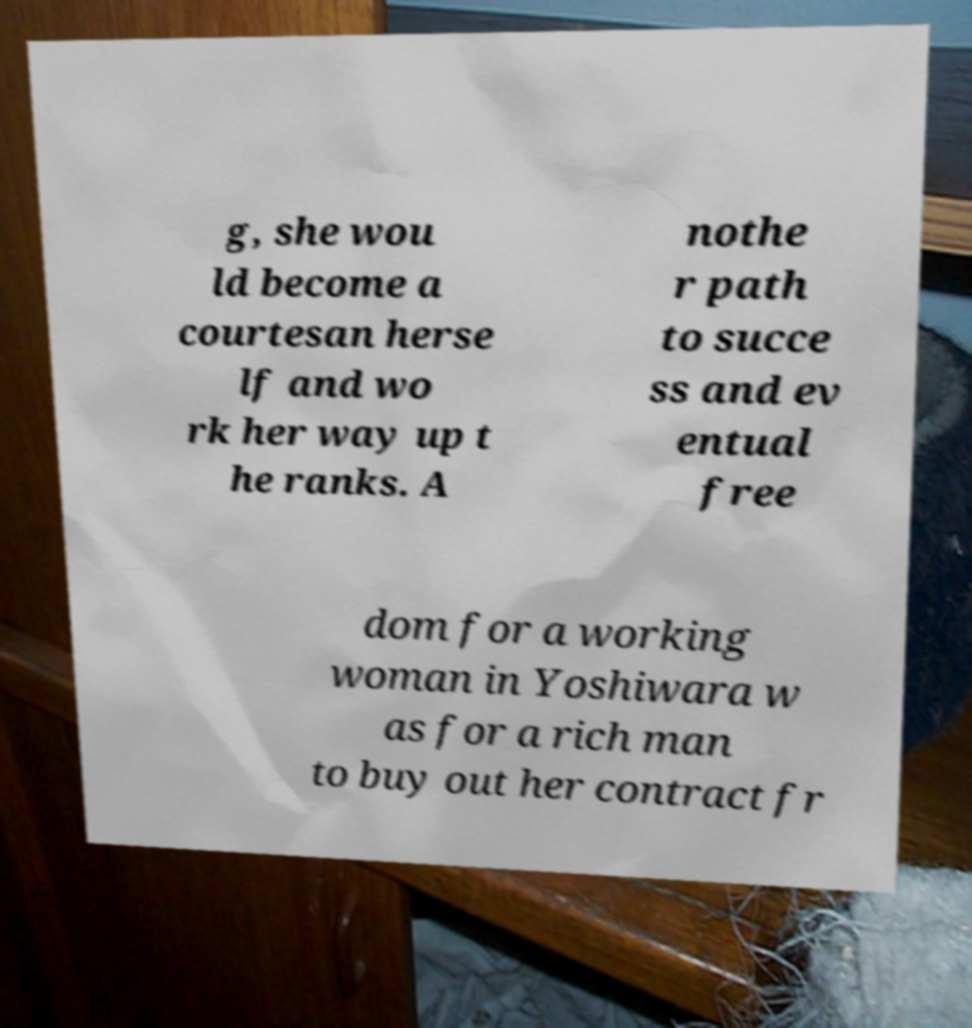Could you assist in decoding the text presented in this image and type it out clearly? g, she wou ld become a courtesan herse lf and wo rk her way up t he ranks. A nothe r path to succe ss and ev entual free dom for a working woman in Yoshiwara w as for a rich man to buy out her contract fr 